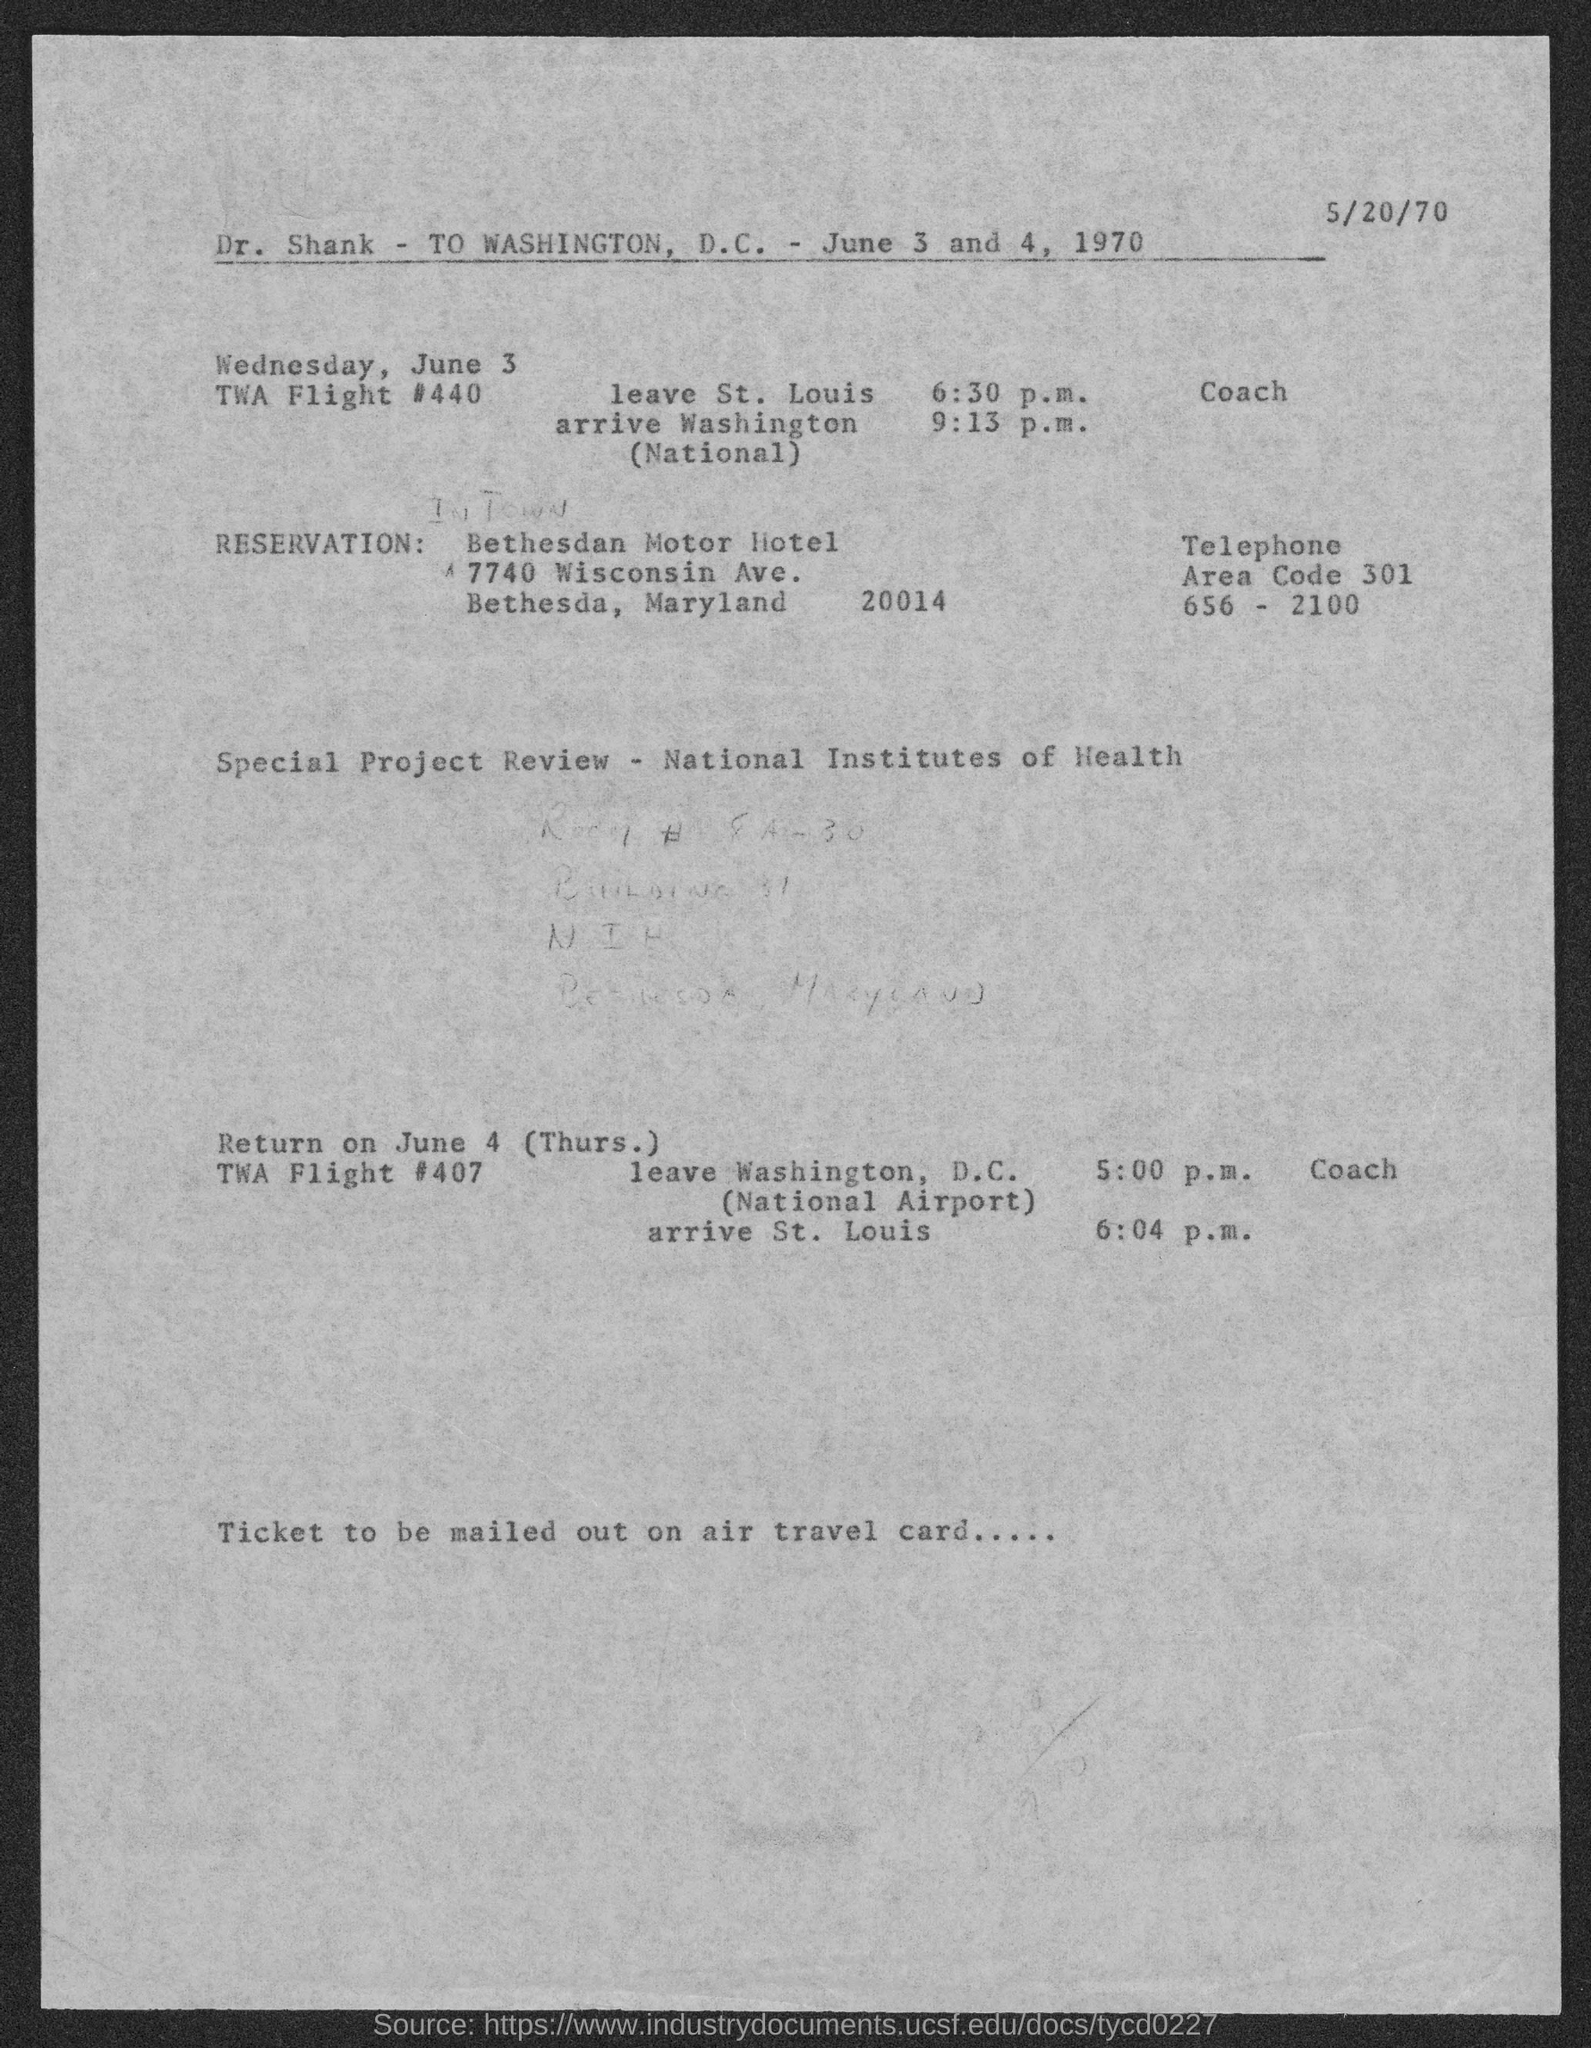Identify some key points in this picture. The return flight is scheduled for June 4th. The zip code for the address listed under 'Reservation' is 20014. The document mentions Dr. Shank's name at the beginning of the document. The departure time of the return flight from Washington, D.C. is 5:00 p.m. 